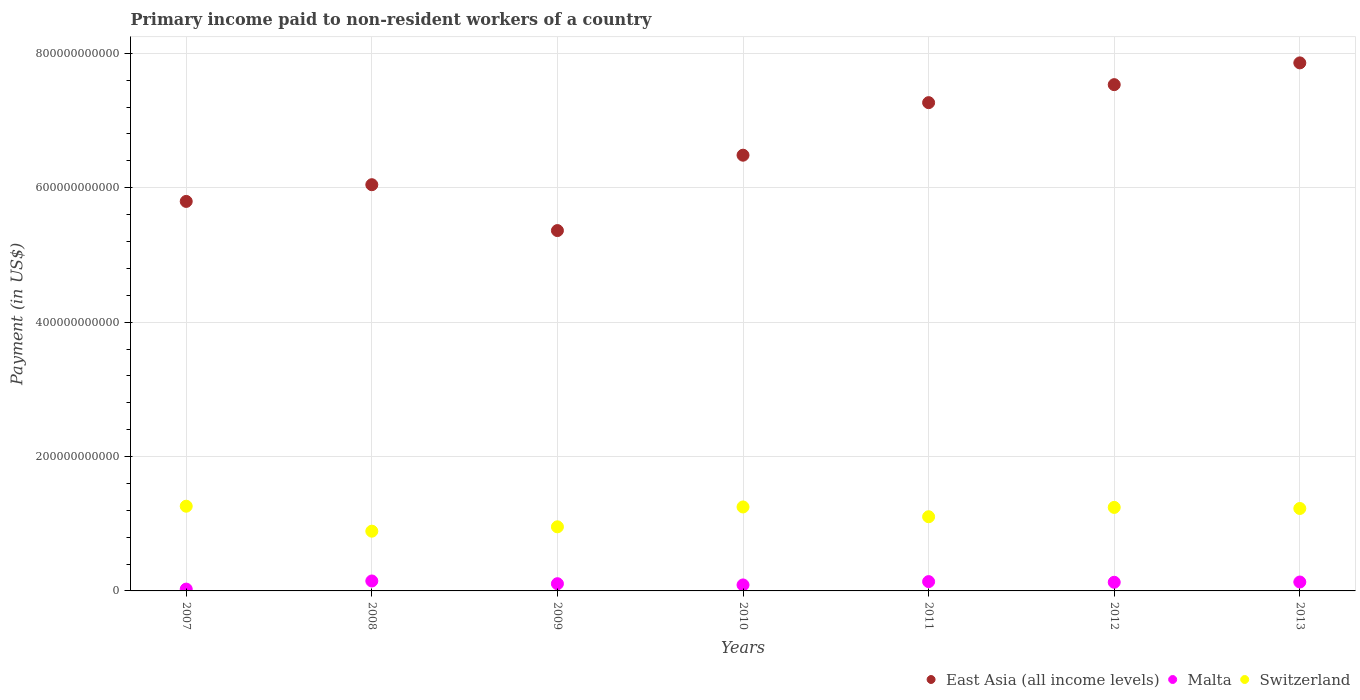Is the number of dotlines equal to the number of legend labels?
Give a very brief answer. Yes. What is the amount paid to workers in East Asia (all income levels) in 2012?
Your response must be concise. 7.53e+11. Across all years, what is the maximum amount paid to workers in Switzerland?
Give a very brief answer. 1.26e+11. Across all years, what is the minimum amount paid to workers in Malta?
Your answer should be compact. 2.71e+09. In which year was the amount paid to workers in Switzerland minimum?
Your answer should be compact. 2008. What is the total amount paid to workers in East Asia (all income levels) in the graph?
Ensure brevity in your answer.  4.63e+12. What is the difference between the amount paid to workers in Malta in 2008 and that in 2012?
Provide a succinct answer. 1.93e+09. What is the difference between the amount paid to workers in Malta in 2011 and the amount paid to workers in Switzerland in 2007?
Ensure brevity in your answer.  -1.12e+11. What is the average amount paid to workers in East Asia (all income levels) per year?
Offer a very short reply. 6.62e+11. In the year 2009, what is the difference between the amount paid to workers in Malta and amount paid to workers in East Asia (all income levels)?
Provide a short and direct response. -5.26e+11. In how many years, is the amount paid to workers in Malta greater than 640000000000 US$?
Provide a short and direct response. 0. What is the ratio of the amount paid to workers in Switzerland in 2011 to that in 2012?
Your answer should be very brief. 0.89. Is the amount paid to workers in East Asia (all income levels) in 2009 less than that in 2013?
Offer a terse response. Yes. Is the difference between the amount paid to workers in Malta in 2007 and 2009 greater than the difference between the amount paid to workers in East Asia (all income levels) in 2007 and 2009?
Offer a very short reply. No. What is the difference between the highest and the second highest amount paid to workers in Switzerland?
Offer a terse response. 1.10e+09. What is the difference between the highest and the lowest amount paid to workers in East Asia (all income levels)?
Offer a terse response. 2.50e+11. Is the sum of the amount paid to workers in East Asia (all income levels) in 2007 and 2010 greater than the maximum amount paid to workers in Switzerland across all years?
Your response must be concise. Yes. Is it the case that in every year, the sum of the amount paid to workers in East Asia (all income levels) and amount paid to workers in Malta  is greater than the amount paid to workers in Switzerland?
Ensure brevity in your answer.  Yes. Is the amount paid to workers in Switzerland strictly less than the amount paid to workers in East Asia (all income levels) over the years?
Provide a succinct answer. Yes. How many dotlines are there?
Make the answer very short. 3. How many years are there in the graph?
Your response must be concise. 7. What is the difference between two consecutive major ticks on the Y-axis?
Keep it short and to the point. 2.00e+11. Where does the legend appear in the graph?
Give a very brief answer. Bottom right. How are the legend labels stacked?
Offer a terse response. Horizontal. What is the title of the graph?
Your answer should be compact. Primary income paid to non-resident workers of a country. What is the label or title of the X-axis?
Ensure brevity in your answer.  Years. What is the label or title of the Y-axis?
Your answer should be very brief. Payment (in US$). What is the Payment (in US$) of East Asia (all income levels) in 2007?
Your answer should be very brief. 5.80e+11. What is the Payment (in US$) in Malta in 2007?
Make the answer very short. 2.71e+09. What is the Payment (in US$) of Switzerland in 2007?
Offer a terse response. 1.26e+11. What is the Payment (in US$) in East Asia (all income levels) in 2008?
Give a very brief answer. 6.05e+11. What is the Payment (in US$) of Malta in 2008?
Keep it short and to the point. 1.48e+1. What is the Payment (in US$) of Switzerland in 2008?
Ensure brevity in your answer.  8.89e+1. What is the Payment (in US$) of East Asia (all income levels) in 2009?
Offer a very short reply. 5.36e+11. What is the Payment (in US$) in Malta in 2009?
Your response must be concise. 1.07e+1. What is the Payment (in US$) of Switzerland in 2009?
Ensure brevity in your answer.  9.54e+1. What is the Payment (in US$) in East Asia (all income levels) in 2010?
Ensure brevity in your answer.  6.48e+11. What is the Payment (in US$) of Malta in 2010?
Your answer should be compact. 8.90e+09. What is the Payment (in US$) in Switzerland in 2010?
Keep it short and to the point. 1.25e+11. What is the Payment (in US$) of East Asia (all income levels) in 2011?
Offer a very short reply. 7.27e+11. What is the Payment (in US$) of Malta in 2011?
Offer a terse response. 1.38e+1. What is the Payment (in US$) in Switzerland in 2011?
Provide a short and direct response. 1.10e+11. What is the Payment (in US$) in East Asia (all income levels) in 2012?
Provide a succinct answer. 7.53e+11. What is the Payment (in US$) of Malta in 2012?
Your answer should be very brief. 1.29e+1. What is the Payment (in US$) of Switzerland in 2012?
Your answer should be very brief. 1.24e+11. What is the Payment (in US$) in East Asia (all income levels) in 2013?
Keep it short and to the point. 7.86e+11. What is the Payment (in US$) of Malta in 2013?
Offer a very short reply. 1.33e+1. What is the Payment (in US$) in Switzerland in 2013?
Give a very brief answer. 1.23e+11. Across all years, what is the maximum Payment (in US$) in East Asia (all income levels)?
Your answer should be compact. 7.86e+11. Across all years, what is the maximum Payment (in US$) of Malta?
Keep it short and to the point. 1.48e+1. Across all years, what is the maximum Payment (in US$) of Switzerland?
Give a very brief answer. 1.26e+11. Across all years, what is the minimum Payment (in US$) of East Asia (all income levels)?
Provide a short and direct response. 5.36e+11. Across all years, what is the minimum Payment (in US$) in Malta?
Offer a very short reply. 2.71e+09. Across all years, what is the minimum Payment (in US$) of Switzerland?
Offer a very short reply. 8.89e+1. What is the total Payment (in US$) in East Asia (all income levels) in the graph?
Offer a terse response. 4.63e+12. What is the total Payment (in US$) in Malta in the graph?
Make the answer very short. 7.71e+1. What is the total Payment (in US$) in Switzerland in the graph?
Provide a succinct answer. 7.93e+11. What is the difference between the Payment (in US$) in East Asia (all income levels) in 2007 and that in 2008?
Your answer should be very brief. -2.49e+1. What is the difference between the Payment (in US$) of Malta in 2007 and that in 2008?
Provide a succinct answer. -1.21e+1. What is the difference between the Payment (in US$) of Switzerland in 2007 and that in 2008?
Provide a succinct answer. 3.72e+1. What is the difference between the Payment (in US$) in East Asia (all income levels) in 2007 and that in 2009?
Keep it short and to the point. 4.34e+1. What is the difference between the Payment (in US$) of Malta in 2007 and that in 2009?
Offer a very short reply. -8.02e+09. What is the difference between the Payment (in US$) in Switzerland in 2007 and that in 2009?
Make the answer very short. 3.07e+1. What is the difference between the Payment (in US$) in East Asia (all income levels) in 2007 and that in 2010?
Keep it short and to the point. -6.88e+1. What is the difference between the Payment (in US$) in Malta in 2007 and that in 2010?
Provide a short and direct response. -6.18e+09. What is the difference between the Payment (in US$) of Switzerland in 2007 and that in 2010?
Make the answer very short. 1.10e+09. What is the difference between the Payment (in US$) of East Asia (all income levels) in 2007 and that in 2011?
Offer a terse response. -1.47e+11. What is the difference between the Payment (in US$) of Malta in 2007 and that in 2011?
Your answer should be compact. -1.11e+1. What is the difference between the Payment (in US$) in Switzerland in 2007 and that in 2011?
Your answer should be compact. 1.57e+1. What is the difference between the Payment (in US$) of East Asia (all income levels) in 2007 and that in 2012?
Make the answer very short. -1.74e+11. What is the difference between the Payment (in US$) in Malta in 2007 and that in 2012?
Offer a terse response. -1.01e+1. What is the difference between the Payment (in US$) of Switzerland in 2007 and that in 2012?
Your answer should be compact. 1.78e+09. What is the difference between the Payment (in US$) of East Asia (all income levels) in 2007 and that in 2013?
Your response must be concise. -2.06e+11. What is the difference between the Payment (in US$) of Malta in 2007 and that in 2013?
Make the answer very short. -1.05e+1. What is the difference between the Payment (in US$) in Switzerland in 2007 and that in 2013?
Give a very brief answer. 3.38e+09. What is the difference between the Payment (in US$) in East Asia (all income levels) in 2008 and that in 2009?
Provide a short and direct response. 6.83e+1. What is the difference between the Payment (in US$) in Malta in 2008 and that in 2009?
Ensure brevity in your answer.  4.06e+09. What is the difference between the Payment (in US$) of Switzerland in 2008 and that in 2009?
Your response must be concise. -6.48e+09. What is the difference between the Payment (in US$) in East Asia (all income levels) in 2008 and that in 2010?
Provide a succinct answer. -4.39e+1. What is the difference between the Payment (in US$) of Malta in 2008 and that in 2010?
Make the answer very short. 5.90e+09. What is the difference between the Payment (in US$) of Switzerland in 2008 and that in 2010?
Your answer should be very brief. -3.60e+1. What is the difference between the Payment (in US$) in East Asia (all income levels) in 2008 and that in 2011?
Give a very brief answer. -1.22e+11. What is the difference between the Payment (in US$) in Malta in 2008 and that in 2011?
Your response must be concise. 9.48e+08. What is the difference between the Payment (in US$) of Switzerland in 2008 and that in 2011?
Provide a short and direct response. -2.15e+1. What is the difference between the Payment (in US$) of East Asia (all income levels) in 2008 and that in 2012?
Your response must be concise. -1.49e+11. What is the difference between the Payment (in US$) of Malta in 2008 and that in 2012?
Provide a succinct answer. 1.93e+09. What is the difference between the Payment (in US$) in Switzerland in 2008 and that in 2012?
Provide a short and direct response. -3.54e+1. What is the difference between the Payment (in US$) in East Asia (all income levels) in 2008 and that in 2013?
Give a very brief answer. -1.81e+11. What is the difference between the Payment (in US$) in Malta in 2008 and that in 2013?
Provide a short and direct response. 1.53e+09. What is the difference between the Payment (in US$) in Switzerland in 2008 and that in 2013?
Your answer should be very brief. -3.38e+1. What is the difference between the Payment (in US$) in East Asia (all income levels) in 2009 and that in 2010?
Your answer should be compact. -1.12e+11. What is the difference between the Payment (in US$) of Malta in 2009 and that in 2010?
Keep it short and to the point. 1.84e+09. What is the difference between the Payment (in US$) of Switzerland in 2009 and that in 2010?
Keep it short and to the point. -2.96e+1. What is the difference between the Payment (in US$) in East Asia (all income levels) in 2009 and that in 2011?
Your response must be concise. -1.90e+11. What is the difference between the Payment (in US$) of Malta in 2009 and that in 2011?
Offer a terse response. -3.11e+09. What is the difference between the Payment (in US$) of Switzerland in 2009 and that in 2011?
Offer a terse response. -1.50e+1. What is the difference between the Payment (in US$) in East Asia (all income levels) in 2009 and that in 2012?
Make the answer very short. -2.17e+11. What is the difference between the Payment (in US$) in Malta in 2009 and that in 2012?
Make the answer very short. -2.13e+09. What is the difference between the Payment (in US$) in Switzerland in 2009 and that in 2012?
Offer a very short reply. -2.89e+1. What is the difference between the Payment (in US$) in East Asia (all income levels) in 2009 and that in 2013?
Provide a succinct answer. -2.50e+11. What is the difference between the Payment (in US$) of Malta in 2009 and that in 2013?
Your response must be concise. -2.53e+09. What is the difference between the Payment (in US$) of Switzerland in 2009 and that in 2013?
Provide a succinct answer. -2.73e+1. What is the difference between the Payment (in US$) in East Asia (all income levels) in 2010 and that in 2011?
Provide a succinct answer. -7.82e+1. What is the difference between the Payment (in US$) in Malta in 2010 and that in 2011?
Offer a very short reply. -4.95e+09. What is the difference between the Payment (in US$) of Switzerland in 2010 and that in 2011?
Offer a very short reply. 1.46e+1. What is the difference between the Payment (in US$) in East Asia (all income levels) in 2010 and that in 2012?
Give a very brief answer. -1.05e+11. What is the difference between the Payment (in US$) in Malta in 2010 and that in 2012?
Ensure brevity in your answer.  -3.97e+09. What is the difference between the Payment (in US$) of Switzerland in 2010 and that in 2012?
Your answer should be compact. 6.81e+08. What is the difference between the Payment (in US$) in East Asia (all income levels) in 2010 and that in 2013?
Your response must be concise. -1.37e+11. What is the difference between the Payment (in US$) of Malta in 2010 and that in 2013?
Make the answer very short. -4.36e+09. What is the difference between the Payment (in US$) of Switzerland in 2010 and that in 2013?
Ensure brevity in your answer.  2.28e+09. What is the difference between the Payment (in US$) in East Asia (all income levels) in 2011 and that in 2012?
Your answer should be compact. -2.68e+1. What is the difference between the Payment (in US$) in Malta in 2011 and that in 2012?
Offer a very short reply. 9.84e+08. What is the difference between the Payment (in US$) of Switzerland in 2011 and that in 2012?
Offer a very short reply. -1.39e+1. What is the difference between the Payment (in US$) in East Asia (all income levels) in 2011 and that in 2013?
Offer a terse response. -5.92e+1. What is the difference between the Payment (in US$) of Malta in 2011 and that in 2013?
Your response must be concise. 5.87e+08. What is the difference between the Payment (in US$) in Switzerland in 2011 and that in 2013?
Your answer should be very brief. -1.23e+1. What is the difference between the Payment (in US$) of East Asia (all income levels) in 2012 and that in 2013?
Give a very brief answer. -3.24e+1. What is the difference between the Payment (in US$) in Malta in 2012 and that in 2013?
Give a very brief answer. -3.98e+08. What is the difference between the Payment (in US$) of Switzerland in 2012 and that in 2013?
Your answer should be very brief. 1.60e+09. What is the difference between the Payment (in US$) of East Asia (all income levels) in 2007 and the Payment (in US$) of Malta in 2008?
Provide a short and direct response. 5.65e+11. What is the difference between the Payment (in US$) in East Asia (all income levels) in 2007 and the Payment (in US$) in Switzerland in 2008?
Your answer should be very brief. 4.91e+11. What is the difference between the Payment (in US$) in Malta in 2007 and the Payment (in US$) in Switzerland in 2008?
Keep it short and to the point. -8.62e+1. What is the difference between the Payment (in US$) in East Asia (all income levels) in 2007 and the Payment (in US$) in Malta in 2009?
Your answer should be compact. 5.69e+11. What is the difference between the Payment (in US$) of East Asia (all income levels) in 2007 and the Payment (in US$) of Switzerland in 2009?
Make the answer very short. 4.84e+11. What is the difference between the Payment (in US$) of Malta in 2007 and the Payment (in US$) of Switzerland in 2009?
Offer a terse response. -9.27e+1. What is the difference between the Payment (in US$) of East Asia (all income levels) in 2007 and the Payment (in US$) of Malta in 2010?
Offer a very short reply. 5.71e+11. What is the difference between the Payment (in US$) of East Asia (all income levels) in 2007 and the Payment (in US$) of Switzerland in 2010?
Provide a succinct answer. 4.55e+11. What is the difference between the Payment (in US$) of Malta in 2007 and the Payment (in US$) of Switzerland in 2010?
Offer a very short reply. -1.22e+11. What is the difference between the Payment (in US$) of East Asia (all income levels) in 2007 and the Payment (in US$) of Malta in 2011?
Provide a short and direct response. 5.66e+11. What is the difference between the Payment (in US$) of East Asia (all income levels) in 2007 and the Payment (in US$) of Switzerland in 2011?
Give a very brief answer. 4.69e+11. What is the difference between the Payment (in US$) in Malta in 2007 and the Payment (in US$) in Switzerland in 2011?
Your answer should be compact. -1.08e+11. What is the difference between the Payment (in US$) in East Asia (all income levels) in 2007 and the Payment (in US$) in Malta in 2012?
Provide a short and direct response. 5.67e+11. What is the difference between the Payment (in US$) of East Asia (all income levels) in 2007 and the Payment (in US$) of Switzerland in 2012?
Offer a very short reply. 4.55e+11. What is the difference between the Payment (in US$) in Malta in 2007 and the Payment (in US$) in Switzerland in 2012?
Keep it short and to the point. -1.22e+11. What is the difference between the Payment (in US$) of East Asia (all income levels) in 2007 and the Payment (in US$) of Malta in 2013?
Give a very brief answer. 5.66e+11. What is the difference between the Payment (in US$) in East Asia (all income levels) in 2007 and the Payment (in US$) in Switzerland in 2013?
Ensure brevity in your answer.  4.57e+11. What is the difference between the Payment (in US$) of Malta in 2007 and the Payment (in US$) of Switzerland in 2013?
Your answer should be compact. -1.20e+11. What is the difference between the Payment (in US$) of East Asia (all income levels) in 2008 and the Payment (in US$) of Malta in 2009?
Your answer should be very brief. 5.94e+11. What is the difference between the Payment (in US$) in East Asia (all income levels) in 2008 and the Payment (in US$) in Switzerland in 2009?
Give a very brief answer. 5.09e+11. What is the difference between the Payment (in US$) in Malta in 2008 and the Payment (in US$) in Switzerland in 2009?
Keep it short and to the point. -8.06e+1. What is the difference between the Payment (in US$) of East Asia (all income levels) in 2008 and the Payment (in US$) of Malta in 2010?
Provide a short and direct response. 5.96e+11. What is the difference between the Payment (in US$) of East Asia (all income levels) in 2008 and the Payment (in US$) of Switzerland in 2010?
Provide a succinct answer. 4.80e+11. What is the difference between the Payment (in US$) of Malta in 2008 and the Payment (in US$) of Switzerland in 2010?
Ensure brevity in your answer.  -1.10e+11. What is the difference between the Payment (in US$) of East Asia (all income levels) in 2008 and the Payment (in US$) of Malta in 2011?
Offer a very short reply. 5.91e+11. What is the difference between the Payment (in US$) in East Asia (all income levels) in 2008 and the Payment (in US$) in Switzerland in 2011?
Provide a short and direct response. 4.94e+11. What is the difference between the Payment (in US$) of Malta in 2008 and the Payment (in US$) of Switzerland in 2011?
Offer a very short reply. -9.56e+1. What is the difference between the Payment (in US$) in East Asia (all income levels) in 2008 and the Payment (in US$) in Malta in 2012?
Make the answer very short. 5.92e+11. What is the difference between the Payment (in US$) of East Asia (all income levels) in 2008 and the Payment (in US$) of Switzerland in 2012?
Keep it short and to the point. 4.80e+11. What is the difference between the Payment (in US$) in Malta in 2008 and the Payment (in US$) in Switzerland in 2012?
Offer a very short reply. -1.09e+11. What is the difference between the Payment (in US$) of East Asia (all income levels) in 2008 and the Payment (in US$) of Malta in 2013?
Your answer should be very brief. 5.91e+11. What is the difference between the Payment (in US$) in East Asia (all income levels) in 2008 and the Payment (in US$) in Switzerland in 2013?
Make the answer very short. 4.82e+11. What is the difference between the Payment (in US$) in Malta in 2008 and the Payment (in US$) in Switzerland in 2013?
Offer a terse response. -1.08e+11. What is the difference between the Payment (in US$) of East Asia (all income levels) in 2009 and the Payment (in US$) of Malta in 2010?
Give a very brief answer. 5.27e+11. What is the difference between the Payment (in US$) of East Asia (all income levels) in 2009 and the Payment (in US$) of Switzerland in 2010?
Provide a succinct answer. 4.11e+11. What is the difference between the Payment (in US$) in Malta in 2009 and the Payment (in US$) in Switzerland in 2010?
Provide a succinct answer. -1.14e+11. What is the difference between the Payment (in US$) of East Asia (all income levels) in 2009 and the Payment (in US$) of Malta in 2011?
Offer a very short reply. 5.22e+11. What is the difference between the Payment (in US$) of East Asia (all income levels) in 2009 and the Payment (in US$) of Switzerland in 2011?
Make the answer very short. 4.26e+11. What is the difference between the Payment (in US$) of Malta in 2009 and the Payment (in US$) of Switzerland in 2011?
Offer a terse response. -9.97e+1. What is the difference between the Payment (in US$) in East Asia (all income levels) in 2009 and the Payment (in US$) in Malta in 2012?
Your answer should be compact. 5.23e+11. What is the difference between the Payment (in US$) in East Asia (all income levels) in 2009 and the Payment (in US$) in Switzerland in 2012?
Ensure brevity in your answer.  4.12e+11. What is the difference between the Payment (in US$) in Malta in 2009 and the Payment (in US$) in Switzerland in 2012?
Give a very brief answer. -1.14e+11. What is the difference between the Payment (in US$) of East Asia (all income levels) in 2009 and the Payment (in US$) of Malta in 2013?
Ensure brevity in your answer.  5.23e+11. What is the difference between the Payment (in US$) of East Asia (all income levels) in 2009 and the Payment (in US$) of Switzerland in 2013?
Make the answer very short. 4.14e+11. What is the difference between the Payment (in US$) in Malta in 2009 and the Payment (in US$) in Switzerland in 2013?
Your answer should be very brief. -1.12e+11. What is the difference between the Payment (in US$) in East Asia (all income levels) in 2010 and the Payment (in US$) in Malta in 2011?
Offer a very short reply. 6.35e+11. What is the difference between the Payment (in US$) in East Asia (all income levels) in 2010 and the Payment (in US$) in Switzerland in 2011?
Offer a very short reply. 5.38e+11. What is the difference between the Payment (in US$) in Malta in 2010 and the Payment (in US$) in Switzerland in 2011?
Your response must be concise. -1.01e+11. What is the difference between the Payment (in US$) in East Asia (all income levels) in 2010 and the Payment (in US$) in Malta in 2012?
Give a very brief answer. 6.36e+11. What is the difference between the Payment (in US$) in East Asia (all income levels) in 2010 and the Payment (in US$) in Switzerland in 2012?
Keep it short and to the point. 5.24e+11. What is the difference between the Payment (in US$) of Malta in 2010 and the Payment (in US$) of Switzerland in 2012?
Provide a short and direct response. -1.15e+11. What is the difference between the Payment (in US$) of East Asia (all income levels) in 2010 and the Payment (in US$) of Malta in 2013?
Offer a terse response. 6.35e+11. What is the difference between the Payment (in US$) in East Asia (all income levels) in 2010 and the Payment (in US$) in Switzerland in 2013?
Ensure brevity in your answer.  5.26e+11. What is the difference between the Payment (in US$) in Malta in 2010 and the Payment (in US$) in Switzerland in 2013?
Ensure brevity in your answer.  -1.14e+11. What is the difference between the Payment (in US$) of East Asia (all income levels) in 2011 and the Payment (in US$) of Malta in 2012?
Your answer should be compact. 7.14e+11. What is the difference between the Payment (in US$) of East Asia (all income levels) in 2011 and the Payment (in US$) of Switzerland in 2012?
Your response must be concise. 6.02e+11. What is the difference between the Payment (in US$) in Malta in 2011 and the Payment (in US$) in Switzerland in 2012?
Provide a succinct answer. -1.10e+11. What is the difference between the Payment (in US$) in East Asia (all income levels) in 2011 and the Payment (in US$) in Malta in 2013?
Your response must be concise. 7.13e+11. What is the difference between the Payment (in US$) of East Asia (all income levels) in 2011 and the Payment (in US$) of Switzerland in 2013?
Offer a very short reply. 6.04e+11. What is the difference between the Payment (in US$) of Malta in 2011 and the Payment (in US$) of Switzerland in 2013?
Offer a very short reply. -1.09e+11. What is the difference between the Payment (in US$) of East Asia (all income levels) in 2012 and the Payment (in US$) of Malta in 2013?
Offer a terse response. 7.40e+11. What is the difference between the Payment (in US$) in East Asia (all income levels) in 2012 and the Payment (in US$) in Switzerland in 2013?
Your response must be concise. 6.31e+11. What is the difference between the Payment (in US$) of Malta in 2012 and the Payment (in US$) of Switzerland in 2013?
Your response must be concise. -1.10e+11. What is the average Payment (in US$) of East Asia (all income levels) per year?
Your answer should be compact. 6.62e+11. What is the average Payment (in US$) in Malta per year?
Make the answer very short. 1.10e+1. What is the average Payment (in US$) in Switzerland per year?
Give a very brief answer. 1.13e+11. In the year 2007, what is the difference between the Payment (in US$) in East Asia (all income levels) and Payment (in US$) in Malta?
Your response must be concise. 5.77e+11. In the year 2007, what is the difference between the Payment (in US$) in East Asia (all income levels) and Payment (in US$) in Switzerland?
Give a very brief answer. 4.54e+11. In the year 2007, what is the difference between the Payment (in US$) in Malta and Payment (in US$) in Switzerland?
Keep it short and to the point. -1.23e+11. In the year 2008, what is the difference between the Payment (in US$) of East Asia (all income levels) and Payment (in US$) of Malta?
Offer a very short reply. 5.90e+11. In the year 2008, what is the difference between the Payment (in US$) of East Asia (all income levels) and Payment (in US$) of Switzerland?
Give a very brief answer. 5.16e+11. In the year 2008, what is the difference between the Payment (in US$) of Malta and Payment (in US$) of Switzerland?
Your response must be concise. -7.41e+1. In the year 2009, what is the difference between the Payment (in US$) in East Asia (all income levels) and Payment (in US$) in Malta?
Offer a terse response. 5.26e+11. In the year 2009, what is the difference between the Payment (in US$) in East Asia (all income levels) and Payment (in US$) in Switzerland?
Your answer should be very brief. 4.41e+11. In the year 2009, what is the difference between the Payment (in US$) of Malta and Payment (in US$) of Switzerland?
Your answer should be very brief. -8.47e+1. In the year 2010, what is the difference between the Payment (in US$) in East Asia (all income levels) and Payment (in US$) in Malta?
Make the answer very short. 6.40e+11. In the year 2010, what is the difference between the Payment (in US$) of East Asia (all income levels) and Payment (in US$) of Switzerland?
Make the answer very short. 5.23e+11. In the year 2010, what is the difference between the Payment (in US$) in Malta and Payment (in US$) in Switzerland?
Give a very brief answer. -1.16e+11. In the year 2011, what is the difference between the Payment (in US$) in East Asia (all income levels) and Payment (in US$) in Malta?
Make the answer very short. 7.13e+11. In the year 2011, what is the difference between the Payment (in US$) in East Asia (all income levels) and Payment (in US$) in Switzerland?
Provide a short and direct response. 6.16e+11. In the year 2011, what is the difference between the Payment (in US$) of Malta and Payment (in US$) of Switzerland?
Your answer should be very brief. -9.65e+1. In the year 2012, what is the difference between the Payment (in US$) of East Asia (all income levels) and Payment (in US$) of Malta?
Offer a terse response. 7.41e+11. In the year 2012, what is the difference between the Payment (in US$) in East Asia (all income levels) and Payment (in US$) in Switzerland?
Ensure brevity in your answer.  6.29e+11. In the year 2012, what is the difference between the Payment (in US$) in Malta and Payment (in US$) in Switzerland?
Ensure brevity in your answer.  -1.11e+11. In the year 2013, what is the difference between the Payment (in US$) in East Asia (all income levels) and Payment (in US$) in Malta?
Provide a short and direct response. 7.73e+11. In the year 2013, what is the difference between the Payment (in US$) in East Asia (all income levels) and Payment (in US$) in Switzerland?
Offer a terse response. 6.63e+11. In the year 2013, what is the difference between the Payment (in US$) in Malta and Payment (in US$) in Switzerland?
Give a very brief answer. -1.09e+11. What is the ratio of the Payment (in US$) of East Asia (all income levels) in 2007 to that in 2008?
Your answer should be very brief. 0.96. What is the ratio of the Payment (in US$) of Malta in 2007 to that in 2008?
Ensure brevity in your answer.  0.18. What is the ratio of the Payment (in US$) in Switzerland in 2007 to that in 2008?
Provide a succinct answer. 1.42. What is the ratio of the Payment (in US$) of East Asia (all income levels) in 2007 to that in 2009?
Provide a short and direct response. 1.08. What is the ratio of the Payment (in US$) of Malta in 2007 to that in 2009?
Your answer should be compact. 0.25. What is the ratio of the Payment (in US$) of Switzerland in 2007 to that in 2009?
Your answer should be very brief. 1.32. What is the ratio of the Payment (in US$) of East Asia (all income levels) in 2007 to that in 2010?
Ensure brevity in your answer.  0.89. What is the ratio of the Payment (in US$) in Malta in 2007 to that in 2010?
Give a very brief answer. 0.3. What is the ratio of the Payment (in US$) in Switzerland in 2007 to that in 2010?
Your answer should be compact. 1.01. What is the ratio of the Payment (in US$) in East Asia (all income levels) in 2007 to that in 2011?
Provide a short and direct response. 0.8. What is the ratio of the Payment (in US$) in Malta in 2007 to that in 2011?
Give a very brief answer. 0.2. What is the ratio of the Payment (in US$) in Switzerland in 2007 to that in 2011?
Offer a very short reply. 1.14. What is the ratio of the Payment (in US$) in East Asia (all income levels) in 2007 to that in 2012?
Provide a succinct answer. 0.77. What is the ratio of the Payment (in US$) in Malta in 2007 to that in 2012?
Keep it short and to the point. 0.21. What is the ratio of the Payment (in US$) of Switzerland in 2007 to that in 2012?
Keep it short and to the point. 1.01. What is the ratio of the Payment (in US$) of East Asia (all income levels) in 2007 to that in 2013?
Provide a short and direct response. 0.74. What is the ratio of the Payment (in US$) in Malta in 2007 to that in 2013?
Offer a terse response. 0.2. What is the ratio of the Payment (in US$) of Switzerland in 2007 to that in 2013?
Your answer should be compact. 1.03. What is the ratio of the Payment (in US$) of East Asia (all income levels) in 2008 to that in 2009?
Your answer should be very brief. 1.13. What is the ratio of the Payment (in US$) of Malta in 2008 to that in 2009?
Provide a short and direct response. 1.38. What is the ratio of the Payment (in US$) of Switzerland in 2008 to that in 2009?
Ensure brevity in your answer.  0.93. What is the ratio of the Payment (in US$) in East Asia (all income levels) in 2008 to that in 2010?
Make the answer very short. 0.93. What is the ratio of the Payment (in US$) in Malta in 2008 to that in 2010?
Offer a terse response. 1.66. What is the ratio of the Payment (in US$) of Switzerland in 2008 to that in 2010?
Give a very brief answer. 0.71. What is the ratio of the Payment (in US$) in East Asia (all income levels) in 2008 to that in 2011?
Offer a very short reply. 0.83. What is the ratio of the Payment (in US$) in Malta in 2008 to that in 2011?
Keep it short and to the point. 1.07. What is the ratio of the Payment (in US$) of Switzerland in 2008 to that in 2011?
Ensure brevity in your answer.  0.81. What is the ratio of the Payment (in US$) in East Asia (all income levels) in 2008 to that in 2012?
Provide a succinct answer. 0.8. What is the ratio of the Payment (in US$) of Malta in 2008 to that in 2012?
Make the answer very short. 1.15. What is the ratio of the Payment (in US$) in Switzerland in 2008 to that in 2012?
Make the answer very short. 0.72. What is the ratio of the Payment (in US$) in East Asia (all income levels) in 2008 to that in 2013?
Offer a very short reply. 0.77. What is the ratio of the Payment (in US$) of Malta in 2008 to that in 2013?
Offer a very short reply. 1.12. What is the ratio of the Payment (in US$) of Switzerland in 2008 to that in 2013?
Ensure brevity in your answer.  0.72. What is the ratio of the Payment (in US$) of East Asia (all income levels) in 2009 to that in 2010?
Make the answer very short. 0.83. What is the ratio of the Payment (in US$) in Malta in 2009 to that in 2010?
Provide a short and direct response. 1.21. What is the ratio of the Payment (in US$) of Switzerland in 2009 to that in 2010?
Make the answer very short. 0.76. What is the ratio of the Payment (in US$) in East Asia (all income levels) in 2009 to that in 2011?
Provide a short and direct response. 0.74. What is the ratio of the Payment (in US$) in Malta in 2009 to that in 2011?
Your answer should be very brief. 0.78. What is the ratio of the Payment (in US$) in Switzerland in 2009 to that in 2011?
Your answer should be compact. 0.86. What is the ratio of the Payment (in US$) in East Asia (all income levels) in 2009 to that in 2012?
Your answer should be compact. 0.71. What is the ratio of the Payment (in US$) in Malta in 2009 to that in 2012?
Keep it short and to the point. 0.83. What is the ratio of the Payment (in US$) of Switzerland in 2009 to that in 2012?
Offer a very short reply. 0.77. What is the ratio of the Payment (in US$) of East Asia (all income levels) in 2009 to that in 2013?
Give a very brief answer. 0.68. What is the ratio of the Payment (in US$) of Malta in 2009 to that in 2013?
Keep it short and to the point. 0.81. What is the ratio of the Payment (in US$) in Switzerland in 2009 to that in 2013?
Your answer should be very brief. 0.78. What is the ratio of the Payment (in US$) in East Asia (all income levels) in 2010 to that in 2011?
Your answer should be very brief. 0.89. What is the ratio of the Payment (in US$) of Malta in 2010 to that in 2011?
Make the answer very short. 0.64. What is the ratio of the Payment (in US$) in Switzerland in 2010 to that in 2011?
Your answer should be compact. 1.13. What is the ratio of the Payment (in US$) of East Asia (all income levels) in 2010 to that in 2012?
Give a very brief answer. 0.86. What is the ratio of the Payment (in US$) of Malta in 2010 to that in 2012?
Offer a terse response. 0.69. What is the ratio of the Payment (in US$) of Switzerland in 2010 to that in 2012?
Offer a very short reply. 1.01. What is the ratio of the Payment (in US$) of East Asia (all income levels) in 2010 to that in 2013?
Make the answer very short. 0.83. What is the ratio of the Payment (in US$) in Malta in 2010 to that in 2013?
Provide a succinct answer. 0.67. What is the ratio of the Payment (in US$) in Switzerland in 2010 to that in 2013?
Your response must be concise. 1.02. What is the ratio of the Payment (in US$) of East Asia (all income levels) in 2011 to that in 2012?
Make the answer very short. 0.96. What is the ratio of the Payment (in US$) of Malta in 2011 to that in 2012?
Your response must be concise. 1.08. What is the ratio of the Payment (in US$) of Switzerland in 2011 to that in 2012?
Ensure brevity in your answer.  0.89. What is the ratio of the Payment (in US$) of East Asia (all income levels) in 2011 to that in 2013?
Offer a very short reply. 0.92. What is the ratio of the Payment (in US$) of Malta in 2011 to that in 2013?
Make the answer very short. 1.04. What is the ratio of the Payment (in US$) of Switzerland in 2011 to that in 2013?
Make the answer very short. 0.9. What is the ratio of the Payment (in US$) of East Asia (all income levels) in 2012 to that in 2013?
Provide a succinct answer. 0.96. What is the ratio of the Payment (in US$) in Switzerland in 2012 to that in 2013?
Give a very brief answer. 1.01. What is the difference between the highest and the second highest Payment (in US$) in East Asia (all income levels)?
Provide a succinct answer. 3.24e+1. What is the difference between the highest and the second highest Payment (in US$) of Malta?
Your response must be concise. 9.48e+08. What is the difference between the highest and the second highest Payment (in US$) of Switzerland?
Give a very brief answer. 1.10e+09. What is the difference between the highest and the lowest Payment (in US$) of East Asia (all income levels)?
Your answer should be compact. 2.50e+11. What is the difference between the highest and the lowest Payment (in US$) of Malta?
Offer a terse response. 1.21e+1. What is the difference between the highest and the lowest Payment (in US$) of Switzerland?
Your answer should be very brief. 3.72e+1. 